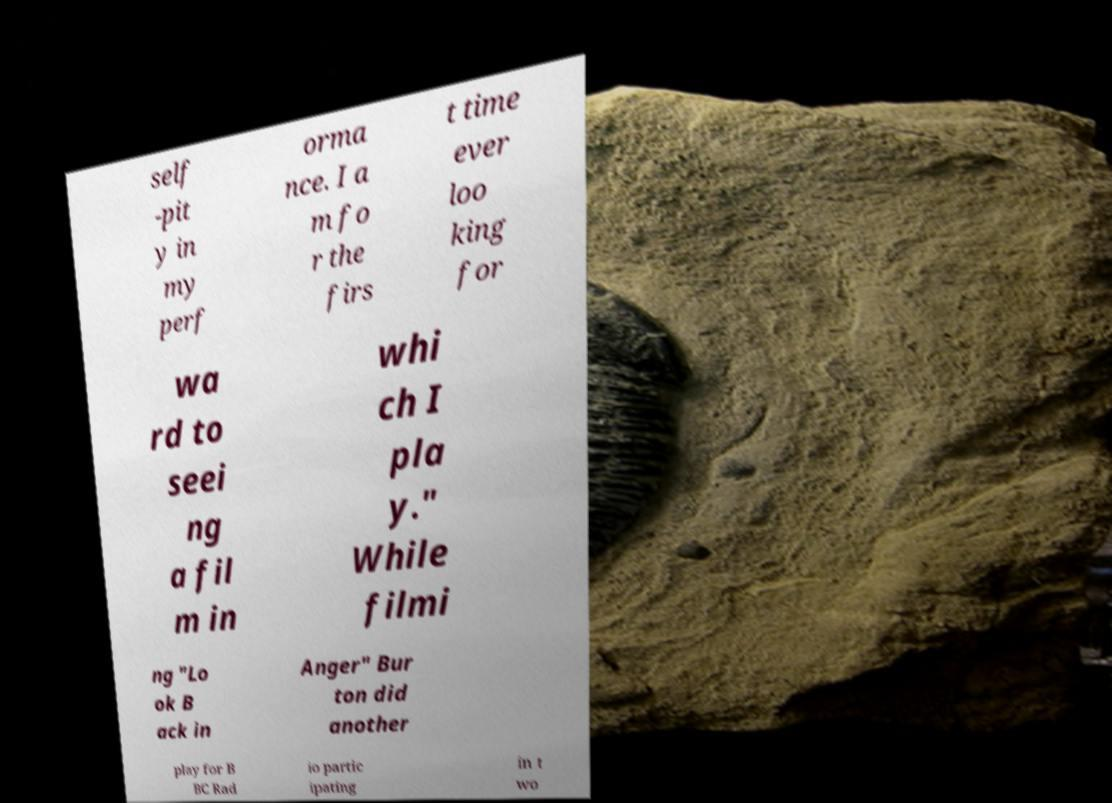There's text embedded in this image that I need extracted. Can you transcribe it verbatim? self -pit y in my perf orma nce. I a m fo r the firs t time ever loo king for wa rd to seei ng a fil m in whi ch I pla y." While filmi ng "Lo ok B ack in Anger" Bur ton did another play for B BC Rad io partic ipating in t wo 